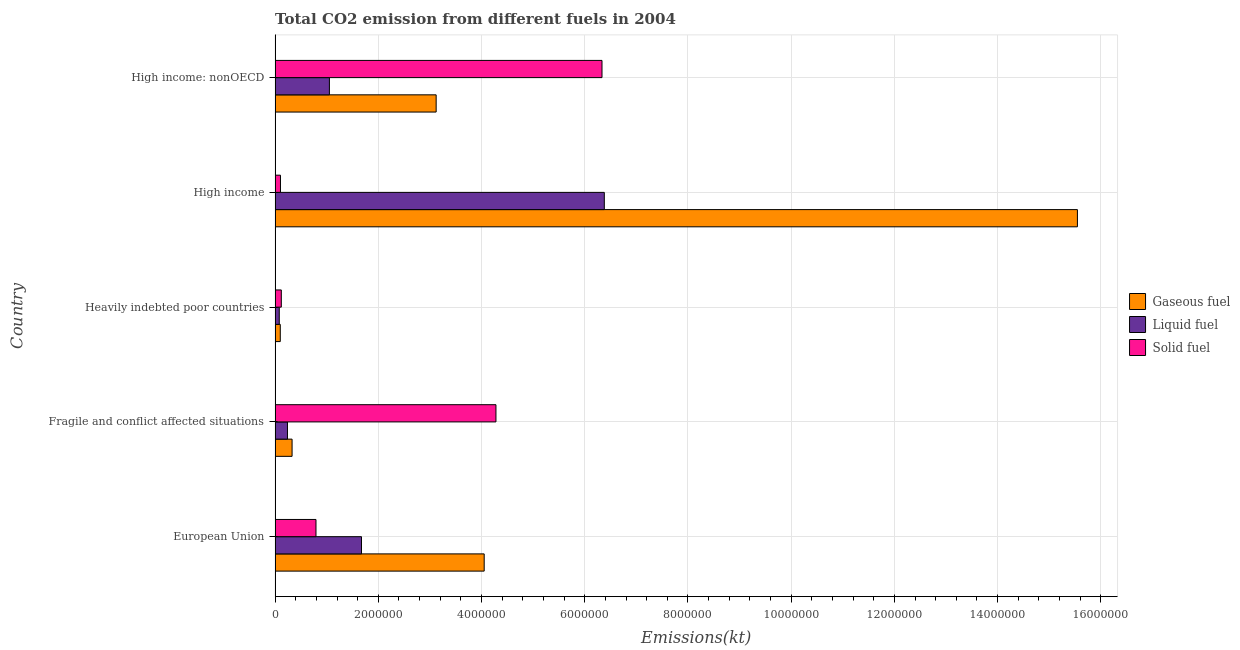How many groups of bars are there?
Provide a succinct answer. 5. What is the label of the 5th group of bars from the top?
Keep it short and to the point. European Union. In how many cases, is the number of bars for a given country not equal to the number of legend labels?
Your response must be concise. 0. What is the amount of co2 emissions from gaseous fuel in European Union?
Provide a succinct answer. 4.05e+06. Across all countries, what is the maximum amount of co2 emissions from solid fuel?
Your response must be concise. 6.33e+06. Across all countries, what is the minimum amount of co2 emissions from liquid fuel?
Keep it short and to the point. 8.10e+04. In which country was the amount of co2 emissions from solid fuel maximum?
Offer a very short reply. High income: nonOECD. In which country was the amount of co2 emissions from gaseous fuel minimum?
Offer a very short reply. Heavily indebted poor countries. What is the total amount of co2 emissions from gaseous fuel in the graph?
Your response must be concise. 2.31e+07. What is the difference between the amount of co2 emissions from liquid fuel in Heavily indebted poor countries and that in High income?
Ensure brevity in your answer.  -6.30e+06. What is the difference between the amount of co2 emissions from liquid fuel in Heavily indebted poor countries and the amount of co2 emissions from solid fuel in Fragile and conflict affected situations?
Provide a succinct answer. -4.20e+06. What is the average amount of co2 emissions from solid fuel per country?
Ensure brevity in your answer.  2.33e+06. What is the difference between the amount of co2 emissions from gaseous fuel and amount of co2 emissions from liquid fuel in Fragile and conflict affected situations?
Offer a very short reply. 8.92e+04. What is the ratio of the amount of co2 emissions from gaseous fuel in Heavily indebted poor countries to that in High income?
Give a very brief answer. 0.01. Is the amount of co2 emissions from liquid fuel in Heavily indebted poor countries less than that in High income?
Offer a very short reply. Yes. Is the difference between the amount of co2 emissions from liquid fuel in European Union and Heavily indebted poor countries greater than the difference between the amount of co2 emissions from gaseous fuel in European Union and Heavily indebted poor countries?
Make the answer very short. No. What is the difference between the highest and the second highest amount of co2 emissions from gaseous fuel?
Your response must be concise. 1.15e+07. What is the difference between the highest and the lowest amount of co2 emissions from gaseous fuel?
Provide a short and direct response. 1.54e+07. In how many countries, is the amount of co2 emissions from liquid fuel greater than the average amount of co2 emissions from liquid fuel taken over all countries?
Provide a short and direct response. 1. Is the sum of the amount of co2 emissions from solid fuel in Heavily indebted poor countries and High income greater than the maximum amount of co2 emissions from gaseous fuel across all countries?
Your answer should be compact. No. What does the 3rd bar from the top in High income represents?
Ensure brevity in your answer.  Gaseous fuel. What does the 2nd bar from the bottom in Heavily indebted poor countries represents?
Ensure brevity in your answer.  Liquid fuel. Is it the case that in every country, the sum of the amount of co2 emissions from gaseous fuel and amount of co2 emissions from liquid fuel is greater than the amount of co2 emissions from solid fuel?
Your answer should be compact. No. How many bars are there?
Provide a succinct answer. 15. Are all the bars in the graph horizontal?
Your answer should be very brief. Yes. What is the difference between two consecutive major ticks on the X-axis?
Give a very brief answer. 2.00e+06. Does the graph contain any zero values?
Your answer should be very brief. No. Where does the legend appear in the graph?
Offer a terse response. Center right. How are the legend labels stacked?
Your response must be concise. Vertical. What is the title of the graph?
Your answer should be compact. Total CO2 emission from different fuels in 2004. Does "Social Protection" appear as one of the legend labels in the graph?
Offer a very short reply. No. What is the label or title of the X-axis?
Your response must be concise. Emissions(kt). What is the label or title of the Y-axis?
Offer a terse response. Country. What is the Emissions(kt) of Gaseous fuel in European Union?
Give a very brief answer. 4.05e+06. What is the Emissions(kt) of Liquid fuel in European Union?
Offer a terse response. 1.67e+06. What is the Emissions(kt) in Solid fuel in European Union?
Keep it short and to the point. 7.93e+05. What is the Emissions(kt) in Gaseous fuel in Fragile and conflict affected situations?
Offer a terse response. 3.29e+05. What is the Emissions(kt) of Liquid fuel in Fragile and conflict affected situations?
Your response must be concise. 2.40e+05. What is the Emissions(kt) of Solid fuel in Fragile and conflict affected situations?
Make the answer very short. 4.28e+06. What is the Emissions(kt) of Gaseous fuel in Heavily indebted poor countries?
Give a very brief answer. 1.01e+05. What is the Emissions(kt) of Liquid fuel in Heavily indebted poor countries?
Keep it short and to the point. 8.10e+04. What is the Emissions(kt) of Solid fuel in Heavily indebted poor countries?
Offer a very short reply. 1.21e+05. What is the Emissions(kt) in Gaseous fuel in High income?
Provide a short and direct response. 1.55e+07. What is the Emissions(kt) of Liquid fuel in High income?
Your response must be concise. 6.38e+06. What is the Emissions(kt) in Solid fuel in High income?
Your response must be concise. 1.04e+05. What is the Emissions(kt) of Gaseous fuel in High income: nonOECD?
Give a very brief answer. 3.12e+06. What is the Emissions(kt) in Liquid fuel in High income: nonOECD?
Give a very brief answer. 1.05e+06. What is the Emissions(kt) in Solid fuel in High income: nonOECD?
Keep it short and to the point. 6.33e+06. Across all countries, what is the maximum Emissions(kt) of Gaseous fuel?
Offer a terse response. 1.55e+07. Across all countries, what is the maximum Emissions(kt) of Liquid fuel?
Provide a succinct answer. 6.38e+06. Across all countries, what is the maximum Emissions(kt) in Solid fuel?
Ensure brevity in your answer.  6.33e+06. Across all countries, what is the minimum Emissions(kt) in Gaseous fuel?
Your answer should be compact. 1.01e+05. Across all countries, what is the minimum Emissions(kt) of Liquid fuel?
Your response must be concise. 8.10e+04. Across all countries, what is the minimum Emissions(kt) in Solid fuel?
Provide a short and direct response. 1.04e+05. What is the total Emissions(kt) in Gaseous fuel in the graph?
Ensure brevity in your answer.  2.31e+07. What is the total Emissions(kt) of Liquid fuel in the graph?
Your answer should be very brief. 9.43e+06. What is the total Emissions(kt) in Solid fuel in the graph?
Offer a terse response. 1.16e+07. What is the difference between the Emissions(kt) of Gaseous fuel in European Union and that in Fragile and conflict affected situations?
Offer a very short reply. 3.72e+06. What is the difference between the Emissions(kt) of Liquid fuel in European Union and that in Fragile and conflict affected situations?
Offer a terse response. 1.43e+06. What is the difference between the Emissions(kt) in Solid fuel in European Union and that in Fragile and conflict affected situations?
Ensure brevity in your answer.  -3.49e+06. What is the difference between the Emissions(kt) of Gaseous fuel in European Union and that in Heavily indebted poor countries?
Provide a succinct answer. 3.95e+06. What is the difference between the Emissions(kt) of Liquid fuel in European Union and that in Heavily indebted poor countries?
Your answer should be compact. 1.59e+06. What is the difference between the Emissions(kt) in Solid fuel in European Union and that in Heavily indebted poor countries?
Provide a succinct answer. 6.72e+05. What is the difference between the Emissions(kt) of Gaseous fuel in European Union and that in High income?
Provide a short and direct response. -1.15e+07. What is the difference between the Emissions(kt) of Liquid fuel in European Union and that in High income?
Offer a terse response. -4.70e+06. What is the difference between the Emissions(kt) in Solid fuel in European Union and that in High income?
Keep it short and to the point. 6.88e+05. What is the difference between the Emissions(kt) in Gaseous fuel in European Union and that in High income: nonOECD?
Provide a succinct answer. 9.31e+05. What is the difference between the Emissions(kt) of Liquid fuel in European Union and that in High income: nonOECD?
Ensure brevity in your answer.  6.22e+05. What is the difference between the Emissions(kt) in Solid fuel in European Union and that in High income: nonOECD?
Offer a terse response. -5.54e+06. What is the difference between the Emissions(kt) of Gaseous fuel in Fragile and conflict affected situations and that in Heavily indebted poor countries?
Offer a terse response. 2.29e+05. What is the difference between the Emissions(kt) in Liquid fuel in Fragile and conflict affected situations and that in Heavily indebted poor countries?
Give a very brief answer. 1.59e+05. What is the difference between the Emissions(kt) of Solid fuel in Fragile and conflict affected situations and that in Heavily indebted poor countries?
Your answer should be compact. 4.16e+06. What is the difference between the Emissions(kt) of Gaseous fuel in Fragile and conflict affected situations and that in High income?
Offer a terse response. -1.52e+07. What is the difference between the Emissions(kt) in Liquid fuel in Fragile and conflict affected situations and that in High income?
Your response must be concise. -6.14e+06. What is the difference between the Emissions(kt) of Solid fuel in Fragile and conflict affected situations and that in High income?
Provide a short and direct response. 4.18e+06. What is the difference between the Emissions(kt) in Gaseous fuel in Fragile and conflict affected situations and that in High income: nonOECD?
Your answer should be very brief. -2.79e+06. What is the difference between the Emissions(kt) in Liquid fuel in Fragile and conflict affected situations and that in High income: nonOECD?
Offer a terse response. -8.12e+05. What is the difference between the Emissions(kt) in Solid fuel in Fragile and conflict affected situations and that in High income: nonOECD?
Provide a succinct answer. -2.05e+06. What is the difference between the Emissions(kt) in Gaseous fuel in Heavily indebted poor countries and that in High income?
Give a very brief answer. -1.54e+07. What is the difference between the Emissions(kt) in Liquid fuel in Heavily indebted poor countries and that in High income?
Give a very brief answer. -6.30e+06. What is the difference between the Emissions(kt) in Solid fuel in Heavily indebted poor countries and that in High income?
Provide a short and direct response. 1.65e+04. What is the difference between the Emissions(kt) of Gaseous fuel in Heavily indebted poor countries and that in High income: nonOECD?
Ensure brevity in your answer.  -3.02e+06. What is the difference between the Emissions(kt) in Liquid fuel in Heavily indebted poor countries and that in High income: nonOECD?
Offer a terse response. -9.72e+05. What is the difference between the Emissions(kt) in Solid fuel in Heavily indebted poor countries and that in High income: nonOECD?
Make the answer very short. -6.21e+06. What is the difference between the Emissions(kt) of Gaseous fuel in High income and that in High income: nonOECD?
Your answer should be compact. 1.24e+07. What is the difference between the Emissions(kt) in Liquid fuel in High income and that in High income: nonOECD?
Keep it short and to the point. 5.33e+06. What is the difference between the Emissions(kt) of Solid fuel in High income and that in High income: nonOECD?
Your response must be concise. -6.23e+06. What is the difference between the Emissions(kt) in Gaseous fuel in European Union and the Emissions(kt) in Liquid fuel in Fragile and conflict affected situations?
Provide a succinct answer. 3.81e+06. What is the difference between the Emissions(kt) in Gaseous fuel in European Union and the Emissions(kt) in Solid fuel in Fragile and conflict affected situations?
Make the answer very short. -2.28e+05. What is the difference between the Emissions(kt) in Liquid fuel in European Union and the Emissions(kt) in Solid fuel in Fragile and conflict affected situations?
Your response must be concise. -2.61e+06. What is the difference between the Emissions(kt) in Gaseous fuel in European Union and the Emissions(kt) in Liquid fuel in Heavily indebted poor countries?
Offer a very short reply. 3.97e+06. What is the difference between the Emissions(kt) of Gaseous fuel in European Union and the Emissions(kt) of Solid fuel in Heavily indebted poor countries?
Ensure brevity in your answer.  3.93e+06. What is the difference between the Emissions(kt) of Liquid fuel in European Union and the Emissions(kt) of Solid fuel in Heavily indebted poor countries?
Provide a short and direct response. 1.55e+06. What is the difference between the Emissions(kt) of Gaseous fuel in European Union and the Emissions(kt) of Liquid fuel in High income?
Ensure brevity in your answer.  -2.33e+06. What is the difference between the Emissions(kt) in Gaseous fuel in European Union and the Emissions(kt) in Solid fuel in High income?
Provide a succinct answer. 3.95e+06. What is the difference between the Emissions(kt) in Liquid fuel in European Union and the Emissions(kt) in Solid fuel in High income?
Offer a terse response. 1.57e+06. What is the difference between the Emissions(kt) of Gaseous fuel in European Union and the Emissions(kt) of Liquid fuel in High income: nonOECD?
Ensure brevity in your answer.  3.00e+06. What is the difference between the Emissions(kt) of Gaseous fuel in European Union and the Emissions(kt) of Solid fuel in High income: nonOECD?
Make the answer very short. -2.28e+06. What is the difference between the Emissions(kt) of Liquid fuel in European Union and the Emissions(kt) of Solid fuel in High income: nonOECD?
Your answer should be very brief. -4.66e+06. What is the difference between the Emissions(kt) of Gaseous fuel in Fragile and conflict affected situations and the Emissions(kt) of Liquid fuel in Heavily indebted poor countries?
Offer a terse response. 2.48e+05. What is the difference between the Emissions(kt) in Gaseous fuel in Fragile and conflict affected situations and the Emissions(kt) in Solid fuel in Heavily indebted poor countries?
Offer a very short reply. 2.09e+05. What is the difference between the Emissions(kt) in Liquid fuel in Fragile and conflict affected situations and the Emissions(kt) in Solid fuel in Heavily indebted poor countries?
Your answer should be compact. 1.19e+05. What is the difference between the Emissions(kt) of Gaseous fuel in Fragile and conflict affected situations and the Emissions(kt) of Liquid fuel in High income?
Offer a very short reply. -6.05e+06. What is the difference between the Emissions(kt) in Gaseous fuel in Fragile and conflict affected situations and the Emissions(kt) in Solid fuel in High income?
Ensure brevity in your answer.  2.25e+05. What is the difference between the Emissions(kt) of Liquid fuel in Fragile and conflict affected situations and the Emissions(kt) of Solid fuel in High income?
Offer a very short reply. 1.36e+05. What is the difference between the Emissions(kt) of Gaseous fuel in Fragile and conflict affected situations and the Emissions(kt) of Liquid fuel in High income: nonOECD?
Offer a terse response. -7.23e+05. What is the difference between the Emissions(kt) of Gaseous fuel in Fragile and conflict affected situations and the Emissions(kt) of Solid fuel in High income: nonOECD?
Ensure brevity in your answer.  -6.01e+06. What is the difference between the Emissions(kt) of Liquid fuel in Fragile and conflict affected situations and the Emissions(kt) of Solid fuel in High income: nonOECD?
Make the answer very short. -6.09e+06. What is the difference between the Emissions(kt) of Gaseous fuel in Heavily indebted poor countries and the Emissions(kt) of Liquid fuel in High income?
Offer a very short reply. -6.28e+06. What is the difference between the Emissions(kt) of Gaseous fuel in Heavily indebted poor countries and the Emissions(kt) of Solid fuel in High income?
Ensure brevity in your answer.  -3520.03. What is the difference between the Emissions(kt) of Liquid fuel in Heavily indebted poor countries and the Emissions(kt) of Solid fuel in High income?
Ensure brevity in your answer.  -2.34e+04. What is the difference between the Emissions(kt) in Gaseous fuel in Heavily indebted poor countries and the Emissions(kt) in Liquid fuel in High income: nonOECD?
Provide a short and direct response. -9.52e+05. What is the difference between the Emissions(kt) of Gaseous fuel in Heavily indebted poor countries and the Emissions(kt) of Solid fuel in High income: nonOECD?
Offer a very short reply. -6.23e+06. What is the difference between the Emissions(kt) of Liquid fuel in Heavily indebted poor countries and the Emissions(kt) of Solid fuel in High income: nonOECD?
Give a very brief answer. -6.25e+06. What is the difference between the Emissions(kt) of Gaseous fuel in High income and the Emissions(kt) of Liquid fuel in High income: nonOECD?
Provide a succinct answer. 1.45e+07. What is the difference between the Emissions(kt) of Gaseous fuel in High income and the Emissions(kt) of Solid fuel in High income: nonOECD?
Give a very brief answer. 9.21e+06. What is the difference between the Emissions(kt) in Liquid fuel in High income and the Emissions(kt) in Solid fuel in High income: nonOECD?
Ensure brevity in your answer.  4.47e+04. What is the average Emissions(kt) of Gaseous fuel per country?
Provide a succinct answer. 4.63e+06. What is the average Emissions(kt) of Liquid fuel per country?
Give a very brief answer. 1.89e+06. What is the average Emissions(kt) of Solid fuel per country?
Your answer should be compact. 2.33e+06. What is the difference between the Emissions(kt) in Gaseous fuel and Emissions(kt) in Liquid fuel in European Union?
Ensure brevity in your answer.  2.38e+06. What is the difference between the Emissions(kt) in Gaseous fuel and Emissions(kt) in Solid fuel in European Union?
Your response must be concise. 3.26e+06. What is the difference between the Emissions(kt) in Liquid fuel and Emissions(kt) in Solid fuel in European Union?
Provide a short and direct response. 8.82e+05. What is the difference between the Emissions(kt) in Gaseous fuel and Emissions(kt) in Liquid fuel in Fragile and conflict affected situations?
Ensure brevity in your answer.  8.92e+04. What is the difference between the Emissions(kt) in Gaseous fuel and Emissions(kt) in Solid fuel in Fragile and conflict affected situations?
Your response must be concise. -3.95e+06. What is the difference between the Emissions(kt) of Liquid fuel and Emissions(kt) of Solid fuel in Fragile and conflict affected situations?
Your response must be concise. -4.04e+06. What is the difference between the Emissions(kt) of Gaseous fuel and Emissions(kt) of Liquid fuel in Heavily indebted poor countries?
Give a very brief answer. 1.98e+04. What is the difference between the Emissions(kt) in Gaseous fuel and Emissions(kt) in Solid fuel in Heavily indebted poor countries?
Your answer should be very brief. -2.00e+04. What is the difference between the Emissions(kt) of Liquid fuel and Emissions(kt) of Solid fuel in Heavily indebted poor countries?
Offer a terse response. -3.98e+04. What is the difference between the Emissions(kt) of Gaseous fuel and Emissions(kt) of Liquid fuel in High income?
Make the answer very short. 9.17e+06. What is the difference between the Emissions(kt) in Gaseous fuel and Emissions(kt) in Solid fuel in High income?
Your answer should be very brief. 1.54e+07. What is the difference between the Emissions(kt) in Liquid fuel and Emissions(kt) in Solid fuel in High income?
Offer a very short reply. 6.27e+06. What is the difference between the Emissions(kt) in Gaseous fuel and Emissions(kt) in Liquid fuel in High income: nonOECD?
Offer a terse response. 2.07e+06. What is the difference between the Emissions(kt) of Gaseous fuel and Emissions(kt) of Solid fuel in High income: nonOECD?
Give a very brief answer. -3.21e+06. What is the difference between the Emissions(kt) in Liquid fuel and Emissions(kt) in Solid fuel in High income: nonOECD?
Your answer should be compact. -5.28e+06. What is the ratio of the Emissions(kt) in Gaseous fuel in European Union to that in Fragile and conflict affected situations?
Your response must be concise. 12.3. What is the ratio of the Emissions(kt) of Liquid fuel in European Union to that in Fragile and conflict affected situations?
Ensure brevity in your answer.  6.97. What is the ratio of the Emissions(kt) of Solid fuel in European Union to that in Fragile and conflict affected situations?
Make the answer very short. 0.19. What is the ratio of the Emissions(kt) in Gaseous fuel in European Union to that in Heavily indebted poor countries?
Offer a very short reply. 40.18. What is the ratio of the Emissions(kt) of Liquid fuel in European Union to that in Heavily indebted poor countries?
Your response must be concise. 20.68. What is the ratio of the Emissions(kt) in Solid fuel in European Union to that in Heavily indebted poor countries?
Provide a short and direct response. 6.56. What is the ratio of the Emissions(kt) of Gaseous fuel in European Union to that in High income?
Give a very brief answer. 0.26. What is the ratio of the Emissions(kt) of Liquid fuel in European Union to that in High income?
Offer a terse response. 0.26. What is the ratio of the Emissions(kt) in Solid fuel in European Union to that in High income?
Keep it short and to the point. 7.6. What is the ratio of the Emissions(kt) in Gaseous fuel in European Union to that in High income: nonOECD?
Ensure brevity in your answer.  1.3. What is the ratio of the Emissions(kt) in Liquid fuel in European Union to that in High income: nonOECD?
Ensure brevity in your answer.  1.59. What is the ratio of the Emissions(kt) of Solid fuel in European Union to that in High income: nonOECD?
Keep it short and to the point. 0.13. What is the ratio of the Emissions(kt) of Gaseous fuel in Fragile and conflict affected situations to that in Heavily indebted poor countries?
Offer a terse response. 3.27. What is the ratio of the Emissions(kt) of Liquid fuel in Fragile and conflict affected situations to that in Heavily indebted poor countries?
Provide a short and direct response. 2.97. What is the ratio of the Emissions(kt) in Solid fuel in Fragile and conflict affected situations to that in Heavily indebted poor countries?
Offer a terse response. 35.42. What is the ratio of the Emissions(kt) in Gaseous fuel in Fragile and conflict affected situations to that in High income?
Give a very brief answer. 0.02. What is the ratio of the Emissions(kt) of Liquid fuel in Fragile and conflict affected situations to that in High income?
Your answer should be compact. 0.04. What is the ratio of the Emissions(kt) in Solid fuel in Fragile and conflict affected situations to that in High income?
Make the answer very short. 41.01. What is the ratio of the Emissions(kt) in Gaseous fuel in Fragile and conflict affected situations to that in High income: nonOECD?
Make the answer very short. 0.11. What is the ratio of the Emissions(kt) of Liquid fuel in Fragile and conflict affected situations to that in High income: nonOECD?
Provide a succinct answer. 0.23. What is the ratio of the Emissions(kt) in Solid fuel in Fragile and conflict affected situations to that in High income: nonOECD?
Give a very brief answer. 0.68. What is the ratio of the Emissions(kt) in Gaseous fuel in Heavily indebted poor countries to that in High income?
Ensure brevity in your answer.  0.01. What is the ratio of the Emissions(kt) of Liquid fuel in Heavily indebted poor countries to that in High income?
Offer a very short reply. 0.01. What is the ratio of the Emissions(kt) of Solid fuel in Heavily indebted poor countries to that in High income?
Your answer should be very brief. 1.16. What is the ratio of the Emissions(kt) of Gaseous fuel in Heavily indebted poor countries to that in High income: nonOECD?
Ensure brevity in your answer.  0.03. What is the ratio of the Emissions(kt) of Liquid fuel in Heavily indebted poor countries to that in High income: nonOECD?
Provide a short and direct response. 0.08. What is the ratio of the Emissions(kt) of Solid fuel in Heavily indebted poor countries to that in High income: nonOECD?
Offer a very short reply. 0.02. What is the ratio of the Emissions(kt) in Gaseous fuel in High income to that in High income: nonOECD?
Your answer should be compact. 4.98. What is the ratio of the Emissions(kt) in Liquid fuel in High income to that in High income: nonOECD?
Give a very brief answer. 6.06. What is the ratio of the Emissions(kt) in Solid fuel in High income to that in High income: nonOECD?
Keep it short and to the point. 0.02. What is the difference between the highest and the second highest Emissions(kt) in Gaseous fuel?
Your answer should be compact. 1.15e+07. What is the difference between the highest and the second highest Emissions(kt) of Liquid fuel?
Provide a succinct answer. 4.70e+06. What is the difference between the highest and the second highest Emissions(kt) in Solid fuel?
Your answer should be very brief. 2.05e+06. What is the difference between the highest and the lowest Emissions(kt) in Gaseous fuel?
Provide a succinct answer. 1.54e+07. What is the difference between the highest and the lowest Emissions(kt) of Liquid fuel?
Provide a succinct answer. 6.30e+06. What is the difference between the highest and the lowest Emissions(kt) in Solid fuel?
Your answer should be compact. 6.23e+06. 